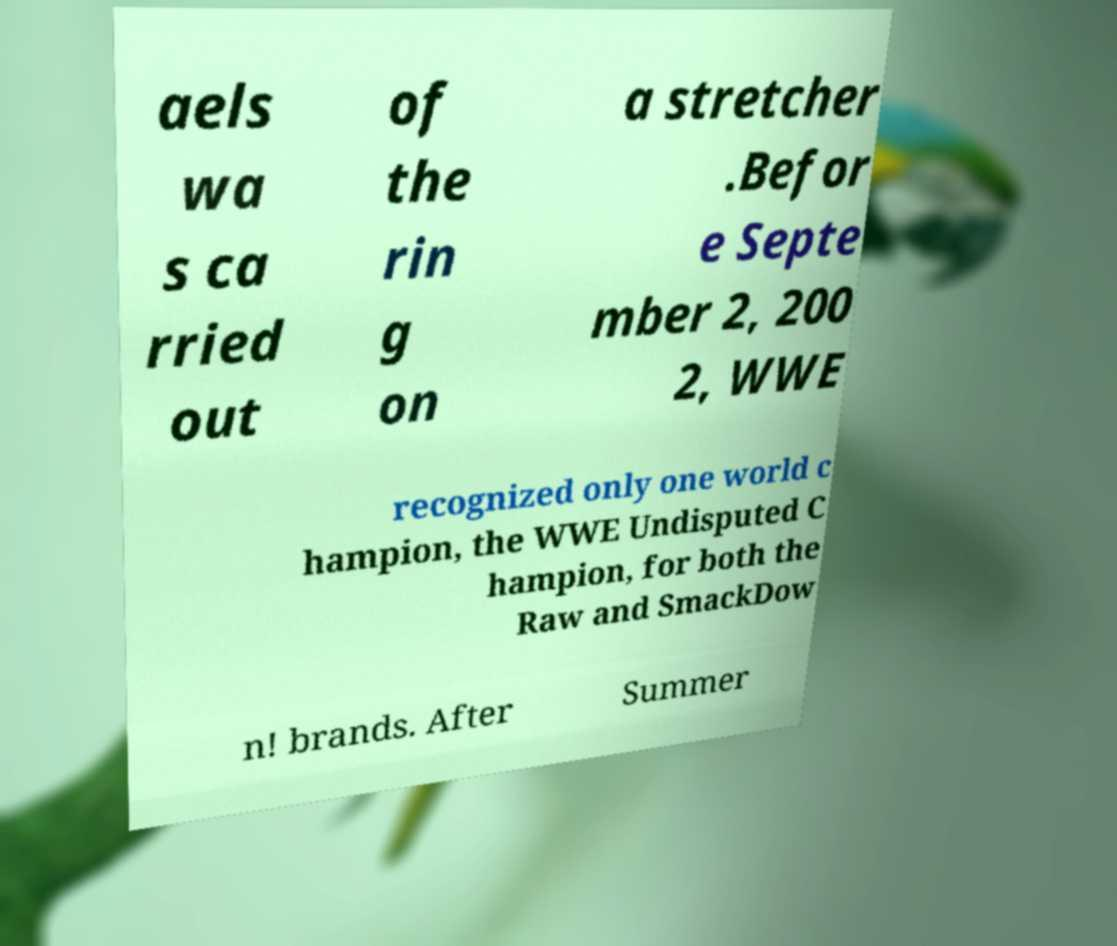Can you read and provide the text displayed in the image?This photo seems to have some interesting text. Can you extract and type it out for me? aels wa s ca rried out of the rin g on a stretcher .Befor e Septe mber 2, 200 2, WWE recognized only one world c hampion, the WWE Undisputed C hampion, for both the Raw and SmackDow n! brands. After Summer 